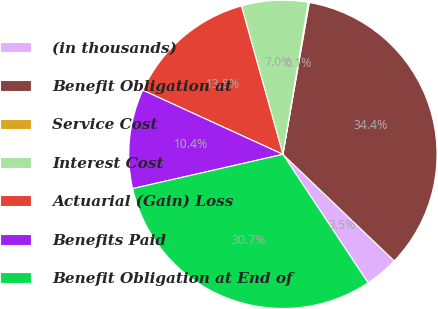<chart> <loc_0><loc_0><loc_500><loc_500><pie_chart><fcel>(in thousands)<fcel>Benefit Obligation at<fcel>Service Cost<fcel>Interest Cost<fcel>Actuarial (Gain) Loss<fcel>Benefits Paid<fcel>Benefit Obligation at End of<nl><fcel>3.54%<fcel>34.41%<fcel>0.11%<fcel>6.97%<fcel>13.83%<fcel>10.4%<fcel>30.75%<nl></chart> 